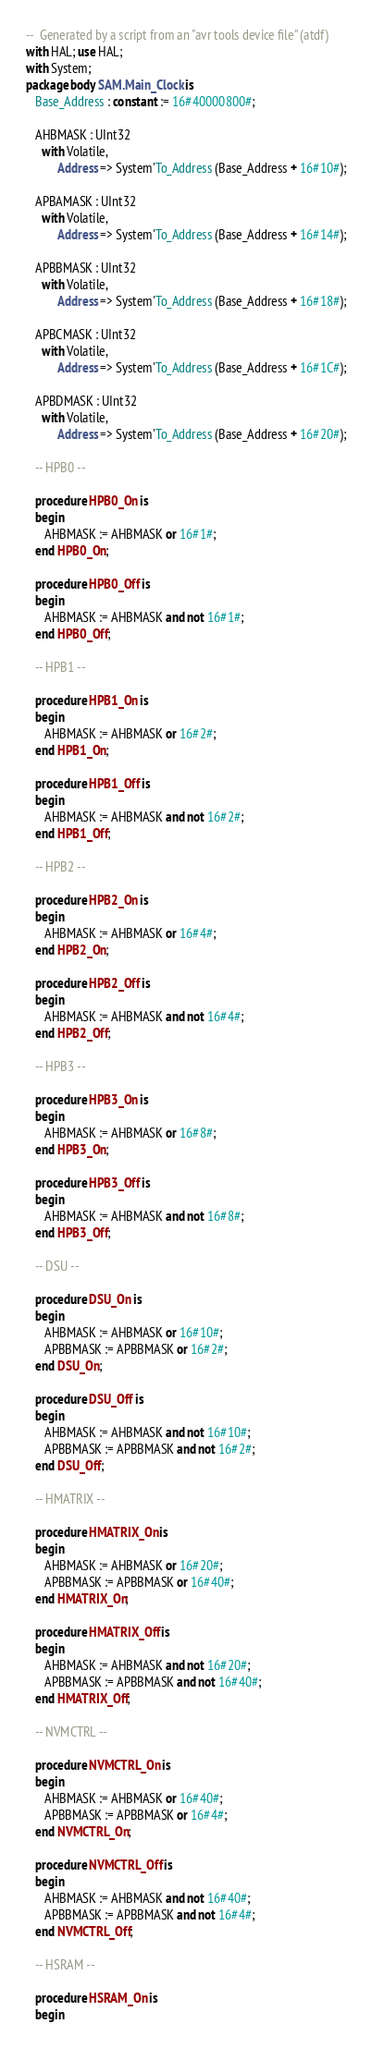Convert code to text. <code><loc_0><loc_0><loc_500><loc_500><_Ada_>--  Generated by a script from an "avr tools device file" (atdf)
with HAL; use HAL;
with System;
package body SAM.Main_Clock is
   Base_Address : constant := 16#40000800#;

   AHBMASK : UInt32
     with Volatile,
          Address => System'To_Address (Base_Address + 16#10#);

   APBAMASK : UInt32
     with Volatile,
          Address => System'To_Address (Base_Address + 16#14#);

   APBBMASK : UInt32
     with Volatile,
          Address => System'To_Address (Base_Address + 16#18#);

   APBCMASK : UInt32
     with Volatile,
          Address => System'To_Address (Base_Address + 16#1C#);

   APBDMASK : UInt32
     with Volatile,
          Address => System'To_Address (Base_Address + 16#20#);

   -- HPB0 --

   procedure HPB0_On is
   begin
      AHBMASK := AHBMASK or 16#1#;
   end HPB0_On;

   procedure HPB0_Off is
   begin
      AHBMASK := AHBMASK and not 16#1#;
   end HPB0_Off;

   -- HPB1 --

   procedure HPB1_On is
   begin
      AHBMASK := AHBMASK or 16#2#;
   end HPB1_On;

   procedure HPB1_Off is
   begin
      AHBMASK := AHBMASK and not 16#2#;
   end HPB1_Off;

   -- HPB2 --

   procedure HPB2_On is
   begin
      AHBMASK := AHBMASK or 16#4#;
   end HPB2_On;

   procedure HPB2_Off is
   begin
      AHBMASK := AHBMASK and not 16#4#;
   end HPB2_Off;

   -- HPB3 --

   procedure HPB3_On is
   begin
      AHBMASK := AHBMASK or 16#8#;
   end HPB3_On;

   procedure HPB3_Off is
   begin
      AHBMASK := AHBMASK and not 16#8#;
   end HPB3_Off;

   -- DSU --

   procedure DSU_On is
   begin
      AHBMASK := AHBMASK or 16#10#;
      APBBMASK := APBBMASK or 16#2#;
   end DSU_On;

   procedure DSU_Off is
   begin
      AHBMASK := AHBMASK and not 16#10#;
      APBBMASK := APBBMASK and not 16#2#;
   end DSU_Off;

   -- HMATRIX --

   procedure HMATRIX_On is
   begin
      AHBMASK := AHBMASK or 16#20#;
      APBBMASK := APBBMASK or 16#40#;
   end HMATRIX_On;

   procedure HMATRIX_Off is
   begin
      AHBMASK := AHBMASK and not 16#20#;
      APBBMASK := APBBMASK and not 16#40#;
   end HMATRIX_Off;

   -- NVMCTRL --

   procedure NVMCTRL_On is
   begin
      AHBMASK := AHBMASK or 16#40#;
      APBBMASK := APBBMASK or 16#4#;
   end NVMCTRL_On;

   procedure NVMCTRL_Off is
   begin
      AHBMASK := AHBMASK and not 16#40#;
      APBBMASK := APBBMASK and not 16#4#;
   end NVMCTRL_Off;

   -- HSRAM --

   procedure HSRAM_On is
   begin</code> 